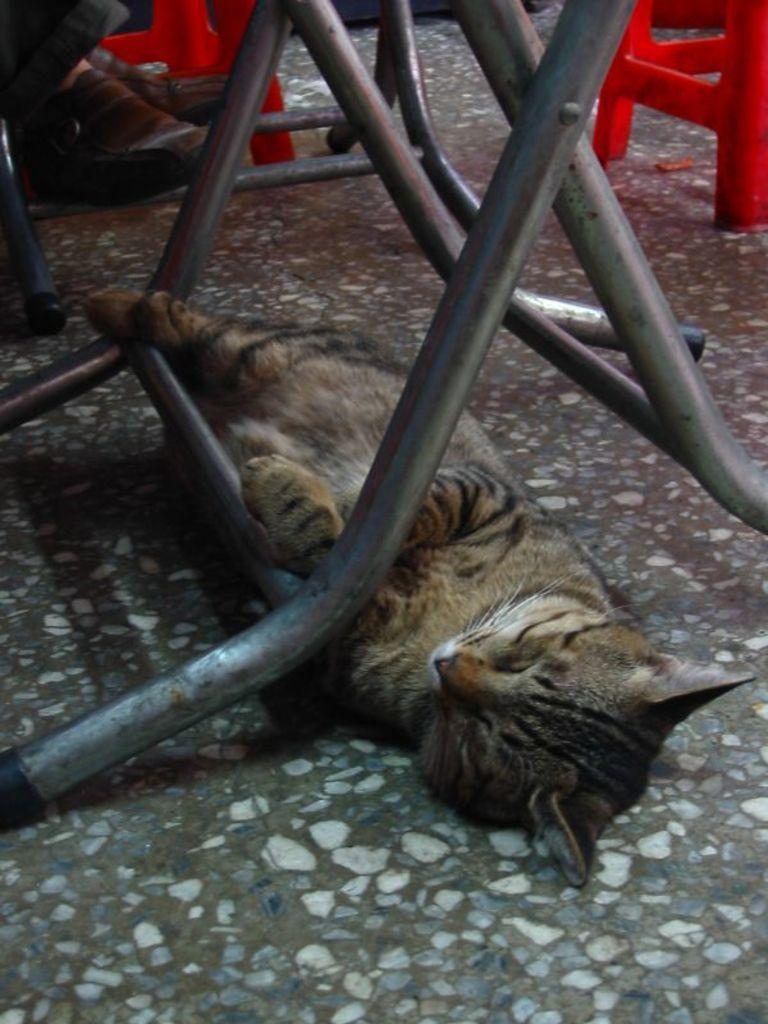In one or two sentences, can you explain what this image depicts? In this image we can see a cat on the floor. There are table rods. There are red color tables. There are legs of a person. 